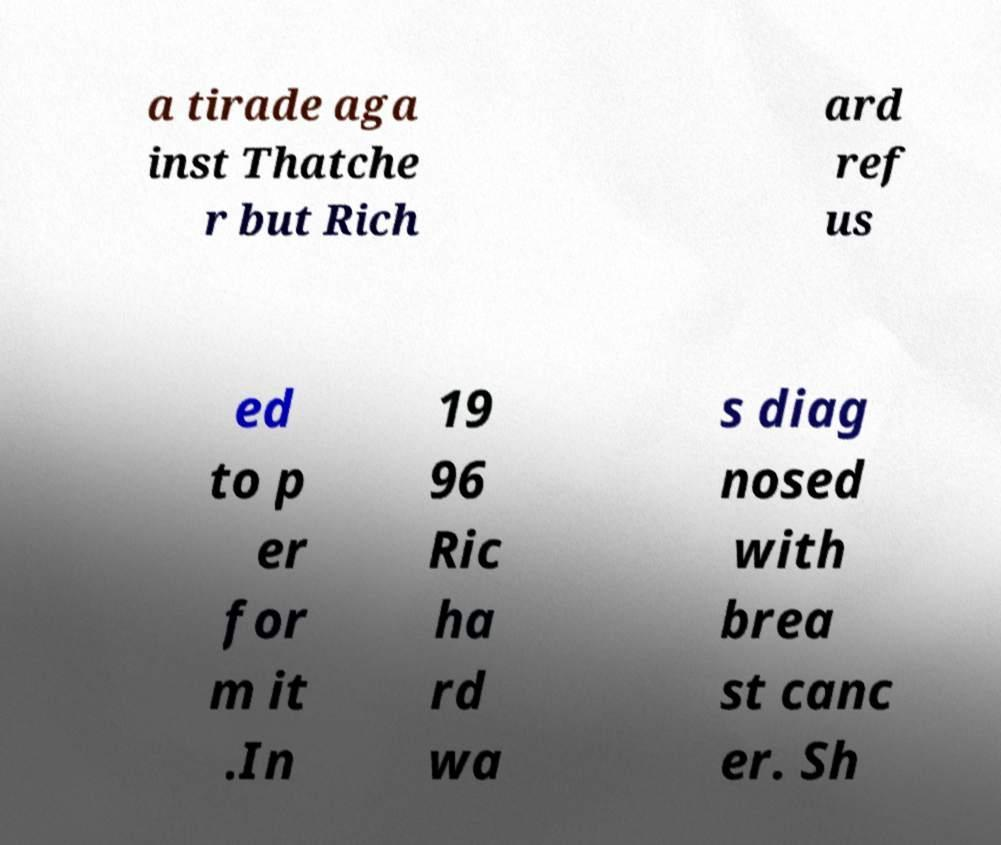Please identify and transcribe the text found in this image. a tirade aga inst Thatche r but Rich ard ref us ed to p er for m it .In 19 96 Ric ha rd wa s diag nosed with brea st canc er. Sh 